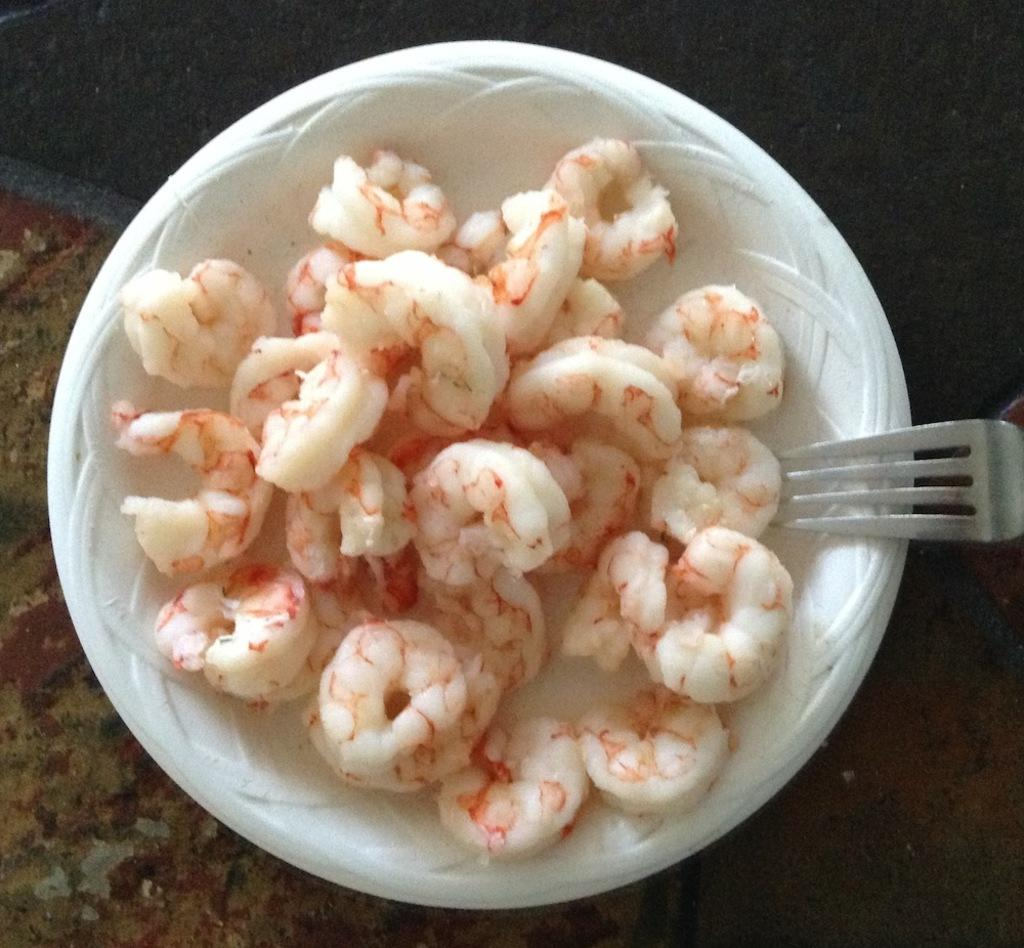What type of food is on the white plate in the image? There are prawns on a white plate in the image. What utensil is placed with the prawns on the plate? There is a fork on the white plate in the image. Where is the white plate located? The white plate is placed on a surface. What can be seen at the top of the image? There is cloth visible at the top of the image. What type of pet is sitting on the brick in the image? There is no pet or brick present in the image. 